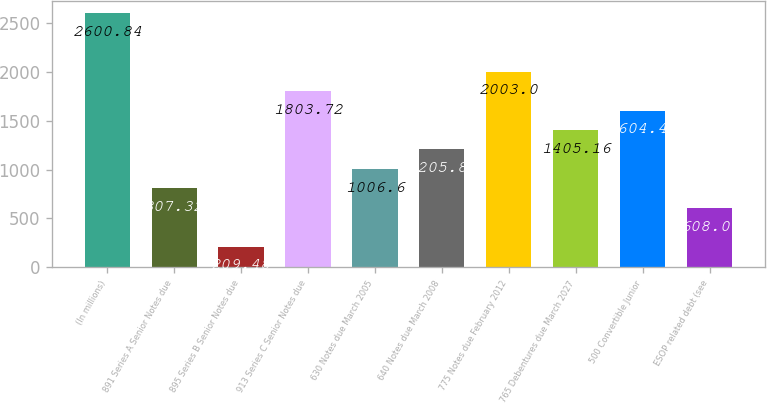Convert chart. <chart><loc_0><loc_0><loc_500><loc_500><bar_chart><fcel>(In millions)<fcel>891 Series A Senior Notes due<fcel>895 Series B Senior Notes due<fcel>913 Series C Senior Notes due<fcel>630 Notes due March 2005<fcel>640 Notes due March 2008<fcel>775 Notes due February 2012<fcel>765 Debentures due March 2027<fcel>500 Convertible Junior<fcel>ESOP related debt (see<nl><fcel>2600.84<fcel>807.32<fcel>209.48<fcel>1803.72<fcel>1006.6<fcel>1205.88<fcel>2003<fcel>1405.16<fcel>1604.44<fcel>608.04<nl></chart> 